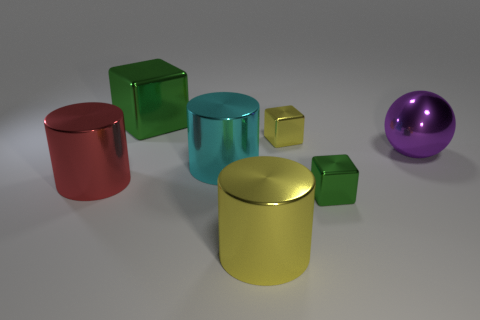Subtract all brown cylinders. How many green blocks are left? 2 Subtract all large cyan cylinders. How many cylinders are left? 2 Subtract 1 cylinders. How many cylinders are left? 2 Add 2 tiny yellow shiny cubes. How many objects exist? 9 Subtract all purple cylinders. Subtract all purple balls. How many cylinders are left? 3 Subtract all spheres. How many objects are left? 6 Add 2 brown balls. How many brown balls exist? 2 Subtract 0 gray cylinders. How many objects are left? 7 Subtract all large metallic things. Subtract all big red shiny cylinders. How many objects are left? 1 Add 6 large cyan shiny things. How many large cyan shiny things are left? 7 